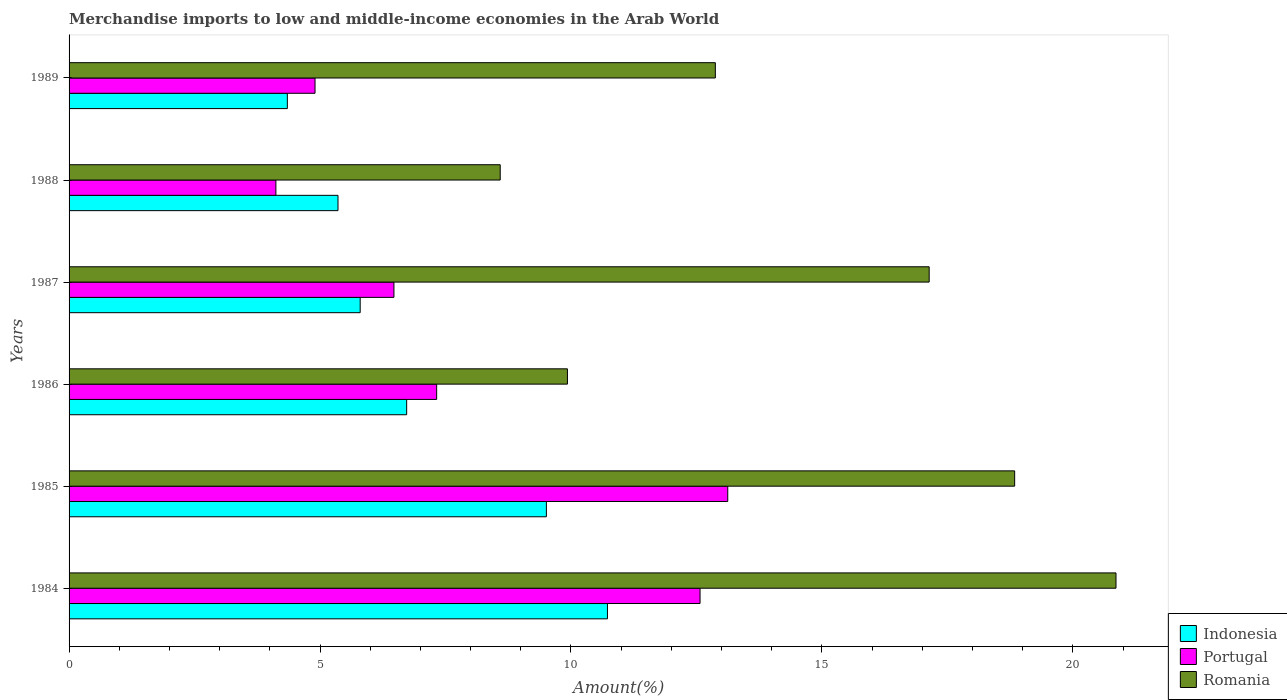How many different coloured bars are there?
Provide a succinct answer. 3. How many groups of bars are there?
Ensure brevity in your answer.  6. Are the number of bars per tick equal to the number of legend labels?
Your response must be concise. Yes. How many bars are there on the 5th tick from the top?
Your answer should be compact. 3. What is the label of the 1st group of bars from the top?
Provide a short and direct response. 1989. What is the percentage of amount earned from merchandise imports in Romania in 1986?
Give a very brief answer. 9.93. Across all years, what is the maximum percentage of amount earned from merchandise imports in Romania?
Ensure brevity in your answer.  20.86. Across all years, what is the minimum percentage of amount earned from merchandise imports in Indonesia?
Provide a succinct answer. 4.35. In which year was the percentage of amount earned from merchandise imports in Portugal maximum?
Offer a terse response. 1985. In which year was the percentage of amount earned from merchandise imports in Romania minimum?
Provide a short and direct response. 1988. What is the total percentage of amount earned from merchandise imports in Romania in the graph?
Make the answer very short. 88.24. What is the difference between the percentage of amount earned from merchandise imports in Portugal in 1985 and that in 1988?
Your response must be concise. 9. What is the difference between the percentage of amount earned from merchandise imports in Romania in 1987 and the percentage of amount earned from merchandise imports in Portugal in 1984?
Make the answer very short. 4.57. What is the average percentage of amount earned from merchandise imports in Indonesia per year?
Your answer should be very brief. 7.08. In the year 1988, what is the difference between the percentage of amount earned from merchandise imports in Romania and percentage of amount earned from merchandise imports in Indonesia?
Your response must be concise. 3.23. In how many years, is the percentage of amount earned from merchandise imports in Indonesia greater than 5 %?
Give a very brief answer. 5. What is the ratio of the percentage of amount earned from merchandise imports in Portugal in 1987 to that in 1989?
Your answer should be very brief. 1.32. Is the percentage of amount earned from merchandise imports in Indonesia in 1986 less than that in 1987?
Offer a very short reply. No. What is the difference between the highest and the second highest percentage of amount earned from merchandise imports in Indonesia?
Keep it short and to the point. 1.22. What is the difference between the highest and the lowest percentage of amount earned from merchandise imports in Romania?
Keep it short and to the point. 12.27. Is the sum of the percentage of amount earned from merchandise imports in Indonesia in 1984 and 1988 greater than the maximum percentage of amount earned from merchandise imports in Romania across all years?
Your answer should be very brief. No. What does the 1st bar from the top in 1988 represents?
Offer a very short reply. Romania. What does the 3rd bar from the bottom in 1986 represents?
Your response must be concise. Romania. How many years are there in the graph?
Make the answer very short. 6. What is the difference between two consecutive major ticks on the X-axis?
Ensure brevity in your answer.  5. Are the values on the major ticks of X-axis written in scientific E-notation?
Your answer should be very brief. No. How are the legend labels stacked?
Provide a succinct answer. Vertical. What is the title of the graph?
Keep it short and to the point. Merchandise imports to low and middle-income economies in the Arab World. What is the label or title of the X-axis?
Your answer should be compact. Amount(%). What is the Amount(%) of Indonesia in 1984?
Offer a very short reply. 10.73. What is the Amount(%) of Portugal in 1984?
Keep it short and to the point. 12.57. What is the Amount(%) of Romania in 1984?
Make the answer very short. 20.86. What is the Amount(%) of Indonesia in 1985?
Your answer should be compact. 9.51. What is the Amount(%) of Portugal in 1985?
Offer a very short reply. 13.12. What is the Amount(%) of Romania in 1985?
Your answer should be very brief. 18.84. What is the Amount(%) of Indonesia in 1986?
Give a very brief answer. 6.73. What is the Amount(%) in Portugal in 1986?
Keep it short and to the point. 7.32. What is the Amount(%) of Romania in 1986?
Offer a terse response. 9.93. What is the Amount(%) in Indonesia in 1987?
Offer a terse response. 5.8. What is the Amount(%) of Portugal in 1987?
Provide a short and direct response. 6.47. What is the Amount(%) of Romania in 1987?
Your response must be concise. 17.14. What is the Amount(%) in Indonesia in 1988?
Provide a short and direct response. 5.36. What is the Amount(%) in Portugal in 1988?
Your answer should be compact. 4.12. What is the Amount(%) of Romania in 1988?
Your response must be concise. 8.59. What is the Amount(%) of Indonesia in 1989?
Make the answer very short. 4.35. What is the Amount(%) in Portugal in 1989?
Make the answer very short. 4.9. What is the Amount(%) of Romania in 1989?
Give a very brief answer. 12.88. Across all years, what is the maximum Amount(%) of Indonesia?
Offer a terse response. 10.73. Across all years, what is the maximum Amount(%) of Portugal?
Provide a short and direct response. 13.12. Across all years, what is the maximum Amount(%) in Romania?
Offer a very short reply. 20.86. Across all years, what is the minimum Amount(%) of Indonesia?
Your answer should be very brief. 4.35. Across all years, what is the minimum Amount(%) in Portugal?
Offer a very short reply. 4.12. Across all years, what is the minimum Amount(%) in Romania?
Keep it short and to the point. 8.59. What is the total Amount(%) of Indonesia in the graph?
Offer a terse response. 42.47. What is the total Amount(%) of Portugal in the graph?
Your answer should be very brief. 48.52. What is the total Amount(%) in Romania in the graph?
Make the answer very short. 88.24. What is the difference between the Amount(%) of Indonesia in 1984 and that in 1985?
Ensure brevity in your answer.  1.22. What is the difference between the Amount(%) of Portugal in 1984 and that in 1985?
Keep it short and to the point. -0.55. What is the difference between the Amount(%) of Romania in 1984 and that in 1985?
Give a very brief answer. 2.02. What is the difference between the Amount(%) in Indonesia in 1984 and that in 1986?
Make the answer very short. 4. What is the difference between the Amount(%) in Portugal in 1984 and that in 1986?
Give a very brief answer. 5.25. What is the difference between the Amount(%) of Romania in 1984 and that in 1986?
Your answer should be very brief. 10.93. What is the difference between the Amount(%) of Indonesia in 1984 and that in 1987?
Make the answer very short. 4.93. What is the difference between the Amount(%) of Portugal in 1984 and that in 1987?
Provide a short and direct response. 6.1. What is the difference between the Amount(%) of Romania in 1984 and that in 1987?
Give a very brief answer. 3.72. What is the difference between the Amount(%) in Indonesia in 1984 and that in 1988?
Offer a very short reply. 5.37. What is the difference between the Amount(%) of Portugal in 1984 and that in 1988?
Offer a terse response. 8.45. What is the difference between the Amount(%) of Romania in 1984 and that in 1988?
Ensure brevity in your answer.  12.27. What is the difference between the Amount(%) of Indonesia in 1984 and that in 1989?
Give a very brief answer. 6.38. What is the difference between the Amount(%) of Portugal in 1984 and that in 1989?
Ensure brevity in your answer.  7.67. What is the difference between the Amount(%) in Romania in 1984 and that in 1989?
Make the answer very short. 7.98. What is the difference between the Amount(%) in Indonesia in 1985 and that in 1986?
Keep it short and to the point. 2.78. What is the difference between the Amount(%) in Portugal in 1985 and that in 1986?
Offer a terse response. 5.8. What is the difference between the Amount(%) in Romania in 1985 and that in 1986?
Give a very brief answer. 8.91. What is the difference between the Amount(%) in Indonesia in 1985 and that in 1987?
Make the answer very short. 3.71. What is the difference between the Amount(%) of Portugal in 1985 and that in 1987?
Offer a very short reply. 6.65. What is the difference between the Amount(%) of Romania in 1985 and that in 1987?
Your response must be concise. 1.7. What is the difference between the Amount(%) in Indonesia in 1985 and that in 1988?
Make the answer very short. 4.15. What is the difference between the Amount(%) in Portugal in 1985 and that in 1988?
Provide a short and direct response. 9. What is the difference between the Amount(%) of Romania in 1985 and that in 1988?
Provide a short and direct response. 10.25. What is the difference between the Amount(%) of Indonesia in 1985 and that in 1989?
Your response must be concise. 5.16. What is the difference between the Amount(%) of Portugal in 1985 and that in 1989?
Offer a very short reply. 8.22. What is the difference between the Amount(%) of Romania in 1985 and that in 1989?
Ensure brevity in your answer.  5.96. What is the difference between the Amount(%) in Indonesia in 1986 and that in 1987?
Ensure brevity in your answer.  0.93. What is the difference between the Amount(%) of Portugal in 1986 and that in 1987?
Your answer should be compact. 0.85. What is the difference between the Amount(%) of Romania in 1986 and that in 1987?
Ensure brevity in your answer.  -7.21. What is the difference between the Amount(%) of Indonesia in 1986 and that in 1988?
Give a very brief answer. 1.37. What is the difference between the Amount(%) of Portugal in 1986 and that in 1988?
Offer a terse response. 3.2. What is the difference between the Amount(%) in Romania in 1986 and that in 1988?
Make the answer very short. 1.34. What is the difference between the Amount(%) in Indonesia in 1986 and that in 1989?
Provide a succinct answer. 2.38. What is the difference between the Amount(%) of Portugal in 1986 and that in 1989?
Your answer should be compact. 2.42. What is the difference between the Amount(%) in Romania in 1986 and that in 1989?
Make the answer very short. -2.95. What is the difference between the Amount(%) of Indonesia in 1987 and that in 1988?
Your answer should be very brief. 0.44. What is the difference between the Amount(%) in Portugal in 1987 and that in 1988?
Offer a very short reply. 2.35. What is the difference between the Amount(%) of Romania in 1987 and that in 1988?
Ensure brevity in your answer.  8.55. What is the difference between the Amount(%) in Indonesia in 1987 and that in 1989?
Offer a very short reply. 1.45. What is the difference between the Amount(%) of Portugal in 1987 and that in 1989?
Provide a succinct answer. 1.57. What is the difference between the Amount(%) of Romania in 1987 and that in 1989?
Provide a short and direct response. 4.26. What is the difference between the Amount(%) in Indonesia in 1988 and that in 1989?
Your answer should be compact. 1.01. What is the difference between the Amount(%) of Portugal in 1988 and that in 1989?
Make the answer very short. -0.78. What is the difference between the Amount(%) in Romania in 1988 and that in 1989?
Give a very brief answer. -4.29. What is the difference between the Amount(%) of Indonesia in 1984 and the Amount(%) of Portugal in 1985?
Ensure brevity in your answer.  -2.4. What is the difference between the Amount(%) of Indonesia in 1984 and the Amount(%) of Romania in 1985?
Keep it short and to the point. -8.11. What is the difference between the Amount(%) of Portugal in 1984 and the Amount(%) of Romania in 1985?
Give a very brief answer. -6.27. What is the difference between the Amount(%) of Indonesia in 1984 and the Amount(%) of Portugal in 1986?
Your answer should be compact. 3.4. What is the difference between the Amount(%) of Indonesia in 1984 and the Amount(%) of Romania in 1986?
Keep it short and to the point. 0.8. What is the difference between the Amount(%) in Portugal in 1984 and the Amount(%) in Romania in 1986?
Keep it short and to the point. 2.64. What is the difference between the Amount(%) of Indonesia in 1984 and the Amount(%) of Portugal in 1987?
Make the answer very short. 4.25. What is the difference between the Amount(%) of Indonesia in 1984 and the Amount(%) of Romania in 1987?
Give a very brief answer. -6.41. What is the difference between the Amount(%) in Portugal in 1984 and the Amount(%) in Romania in 1987?
Your answer should be very brief. -4.57. What is the difference between the Amount(%) of Indonesia in 1984 and the Amount(%) of Portugal in 1988?
Provide a short and direct response. 6.61. What is the difference between the Amount(%) in Indonesia in 1984 and the Amount(%) in Romania in 1988?
Provide a short and direct response. 2.14. What is the difference between the Amount(%) of Portugal in 1984 and the Amount(%) of Romania in 1988?
Provide a succinct answer. 3.98. What is the difference between the Amount(%) of Indonesia in 1984 and the Amount(%) of Portugal in 1989?
Your response must be concise. 5.83. What is the difference between the Amount(%) in Indonesia in 1984 and the Amount(%) in Romania in 1989?
Provide a short and direct response. -2.15. What is the difference between the Amount(%) in Portugal in 1984 and the Amount(%) in Romania in 1989?
Your answer should be compact. -0.3. What is the difference between the Amount(%) in Indonesia in 1985 and the Amount(%) in Portugal in 1986?
Your response must be concise. 2.19. What is the difference between the Amount(%) of Indonesia in 1985 and the Amount(%) of Romania in 1986?
Offer a terse response. -0.42. What is the difference between the Amount(%) in Portugal in 1985 and the Amount(%) in Romania in 1986?
Your response must be concise. 3.19. What is the difference between the Amount(%) in Indonesia in 1985 and the Amount(%) in Portugal in 1987?
Provide a short and direct response. 3.04. What is the difference between the Amount(%) in Indonesia in 1985 and the Amount(%) in Romania in 1987?
Make the answer very short. -7.63. What is the difference between the Amount(%) in Portugal in 1985 and the Amount(%) in Romania in 1987?
Your answer should be compact. -4.01. What is the difference between the Amount(%) in Indonesia in 1985 and the Amount(%) in Portugal in 1988?
Provide a short and direct response. 5.39. What is the difference between the Amount(%) of Indonesia in 1985 and the Amount(%) of Romania in 1988?
Provide a short and direct response. 0.92. What is the difference between the Amount(%) in Portugal in 1985 and the Amount(%) in Romania in 1988?
Give a very brief answer. 4.53. What is the difference between the Amount(%) of Indonesia in 1985 and the Amount(%) of Portugal in 1989?
Your answer should be very brief. 4.61. What is the difference between the Amount(%) in Indonesia in 1985 and the Amount(%) in Romania in 1989?
Your answer should be very brief. -3.37. What is the difference between the Amount(%) of Portugal in 1985 and the Amount(%) of Romania in 1989?
Provide a short and direct response. 0.25. What is the difference between the Amount(%) in Indonesia in 1986 and the Amount(%) in Portugal in 1987?
Offer a terse response. 0.25. What is the difference between the Amount(%) of Indonesia in 1986 and the Amount(%) of Romania in 1987?
Provide a short and direct response. -10.41. What is the difference between the Amount(%) in Portugal in 1986 and the Amount(%) in Romania in 1987?
Give a very brief answer. -9.81. What is the difference between the Amount(%) of Indonesia in 1986 and the Amount(%) of Portugal in 1988?
Ensure brevity in your answer.  2.61. What is the difference between the Amount(%) in Indonesia in 1986 and the Amount(%) in Romania in 1988?
Offer a terse response. -1.86. What is the difference between the Amount(%) in Portugal in 1986 and the Amount(%) in Romania in 1988?
Provide a succinct answer. -1.27. What is the difference between the Amount(%) of Indonesia in 1986 and the Amount(%) of Portugal in 1989?
Keep it short and to the point. 1.83. What is the difference between the Amount(%) in Indonesia in 1986 and the Amount(%) in Romania in 1989?
Offer a terse response. -6.15. What is the difference between the Amount(%) in Portugal in 1986 and the Amount(%) in Romania in 1989?
Offer a terse response. -5.55. What is the difference between the Amount(%) in Indonesia in 1987 and the Amount(%) in Portugal in 1988?
Offer a very short reply. 1.68. What is the difference between the Amount(%) in Indonesia in 1987 and the Amount(%) in Romania in 1988?
Give a very brief answer. -2.79. What is the difference between the Amount(%) of Portugal in 1987 and the Amount(%) of Romania in 1988?
Keep it short and to the point. -2.12. What is the difference between the Amount(%) in Indonesia in 1987 and the Amount(%) in Romania in 1989?
Provide a short and direct response. -7.08. What is the difference between the Amount(%) of Portugal in 1987 and the Amount(%) of Romania in 1989?
Provide a succinct answer. -6.4. What is the difference between the Amount(%) of Indonesia in 1988 and the Amount(%) of Portugal in 1989?
Provide a succinct answer. 0.46. What is the difference between the Amount(%) in Indonesia in 1988 and the Amount(%) in Romania in 1989?
Your response must be concise. -7.52. What is the difference between the Amount(%) of Portugal in 1988 and the Amount(%) of Romania in 1989?
Your answer should be very brief. -8.76. What is the average Amount(%) of Indonesia per year?
Ensure brevity in your answer.  7.08. What is the average Amount(%) in Portugal per year?
Ensure brevity in your answer.  8.09. What is the average Amount(%) in Romania per year?
Ensure brevity in your answer.  14.71. In the year 1984, what is the difference between the Amount(%) of Indonesia and Amount(%) of Portugal?
Your answer should be very brief. -1.84. In the year 1984, what is the difference between the Amount(%) in Indonesia and Amount(%) in Romania?
Keep it short and to the point. -10.13. In the year 1984, what is the difference between the Amount(%) in Portugal and Amount(%) in Romania?
Your answer should be compact. -8.29. In the year 1985, what is the difference between the Amount(%) in Indonesia and Amount(%) in Portugal?
Provide a succinct answer. -3.61. In the year 1985, what is the difference between the Amount(%) in Indonesia and Amount(%) in Romania?
Give a very brief answer. -9.33. In the year 1985, what is the difference between the Amount(%) in Portugal and Amount(%) in Romania?
Offer a very short reply. -5.72. In the year 1986, what is the difference between the Amount(%) of Indonesia and Amount(%) of Portugal?
Ensure brevity in your answer.  -0.6. In the year 1986, what is the difference between the Amount(%) in Indonesia and Amount(%) in Romania?
Offer a terse response. -3.2. In the year 1986, what is the difference between the Amount(%) of Portugal and Amount(%) of Romania?
Give a very brief answer. -2.61. In the year 1987, what is the difference between the Amount(%) of Indonesia and Amount(%) of Portugal?
Offer a very short reply. -0.67. In the year 1987, what is the difference between the Amount(%) of Indonesia and Amount(%) of Romania?
Make the answer very short. -11.34. In the year 1987, what is the difference between the Amount(%) in Portugal and Amount(%) in Romania?
Ensure brevity in your answer.  -10.66. In the year 1988, what is the difference between the Amount(%) in Indonesia and Amount(%) in Portugal?
Provide a succinct answer. 1.24. In the year 1988, what is the difference between the Amount(%) in Indonesia and Amount(%) in Romania?
Keep it short and to the point. -3.23. In the year 1988, what is the difference between the Amount(%) of Portugal and Amount(%) of Romania?
Your answer should be compact. -4.47. In the year 1989, what is the difference between the Amount(%) in Indonesia and Amount(%) in Portugal?
Offer a terse response. -0.55. In the year 1989, what is the difference between the Amount(%) of Indonesia and Amount(%) of Romania?
Make the answer very short. -8.53. In the year 1989, what is the difference between the Amount(%) in Portugal and Amount(%) in Romania?
Make the answer very short. -7.98. What is the ratio of the Amount(%) in Indonesia in 1984 to that in 1985?
Give a very brief answer. 1.13. What is the ratio of the Amount(%) of Portugal in 1984 to that in 1985?
Your answer should be very brief. 0.96. What is the ratio of the Amount(%) in Romania in 1984 to that in 1985?
Offer a terse response. 1.11. What is the ratio of the Amount(%) in Indonesia in 1984 to that in 1986?
Your answer should be very brief. 1.59. What is the ratio of the Amount(%) in Portugal in 1984 to that in 1986?
Make the answer very short. 1.72. What is the ratio of the Amount(%) in Romania in 1984 to that in 1986?
Provide a succinct answer. 2.1. What is the ratio of the Amount(%) of Indonesia in 1984 to that in 1987?
Provide a succinct answer. 1.85. What is the ratio of the Amount(%) of Portugal in 1984 to that in 1987?
Your response must be concise. 1.94. What is the ratio of the Amount(%) of Romania in 1984 to that in 1987?
Offer a very short reply. 1.22. What is the ratio of the Amount(%) in Indonesia in 1984 to that in 1988?
Keep it short and to the point. 2. What is the ratio of the Amount(%) in Portugal in 1984 to that in 1988?
Ensure brevity in your answer.  3.05. What is the ratio of the Amount(%) in Romania in 1984 to that in 1988?
Make the answer very short. 2.43. What is the ratio of the Amount(%) of Indonesia in 1984 to that in 1989?
Provide a succinct answer. 2.47. What is the ratio of the Amount(%) of Portugal in 1984 to that in 1989?
Ensure brevity in your answer.  2.57. What is the ratio of the Amount(%) of Romania in 1984 to that in 1989?
Ensure brevity in your answer.  1.62. What is the ratio of the Amount(%) in Indonesia in 1985 to that in 1986?
Your answer should be compact. 1.41. What is the ratio of the Amount(%) in Portugal in 1985 to that in 1986?
Provide a short and direct response. 1.79. What is the ratio of the Amount(%) of Romania in 1985 to that in 1986?
Give a very brief answer. 1.9. What is the ratio of the Amount(%) of Indonesia in 1985 to that in 1987?
Offer a very short reply. 1.64. What is the ratio of the Amount(%) of Portugal in 1985 to that in 1987?
Offer a very short reply. 2.03. What is the ratio of the Amount(%) in Romania in 1985 to that in 1987?
Make the answer very short. 1.1. What is the ratio of the Amount(%) of Indonesia in 1985 to that in 1988?
Your response must be concise. 1.77. What is the ratio of the Amount(%) of Portugal in 1985 to that in 1988?
Offer a terse response. 3.18. What is the ratio of the Amount(%) in Romania in 1985 to that in 1988?
Give a very brief answer. 2.19. What is the ratio of the Amount(%) in Indonesia in 1985 to that in 1989?
Offer a very short reply. 2.19. What is the ratio of the Amount(%) of Portugal in 1985 to that in 1989?
Your response must be concise. 2.68. What is the ratio of the Amount(%) in Romania in 1985 to that in 1989?
Make the answer very short. 1.46. What is the ratio of the Amount(%) of Indonesia in 1986 to that in 1987?
Keep it short and to the point. 1.16. What is the ratio of the Amount(%) in Portugal in 1986 to that in 1987?
Provide a short and direct response. 1.13. What is the ratio of the Amount(%) of Romania in 1986 to that in 1987?
Your response must be concise. 0.58. What is the ratio of the Amount(%) in Indonesia in 1986 to that in 1988?
Offer a terse response. 1.26. What is the ratio of the Amount(%) of Portugal in 1986 to that in 1988?
Your answer should be compact. 1.78. What is the ratio of the Amount(%) of Romania in 1986 to that in 1988?
Provide a succinct answer. 1.16. What is the ratio of the Amount(%) of Indonesia in 1986 to that in 1989?
Ensure brevity in your answer.  1.55. What is the ratio of the Amount(%) in Portugal in 1986 to that in 1989?
Provide a short and direct response. 1.49. What is the ratio of the Amount(%) of Romania in 1986 to that in 1989?
Make the answer very short. 0.77. What is the ratio of the Amount(%) in Indonesia in 1987 to that in 1988?
Offer a very short reply. 1.08. What is the ratio of the Amount(%) of Portugal in 1987 to that in 1988?
Offer a very short reply. 1.57. What is the ratio of the Amount(%) in Romania in 1987 to that in 1988?
Offer a very short reply. 1.99. What is the ratio of the Amount(%) of Indonesia in 1987 to that in 1989?
Give a very brief answer. 1.33. What is the ratio of the Amount(%) of Portugal in 1987 to that in 1989?
Ensure brevity in your answer.  1.32. What is the ratio of the Amount(%) of Romania in 1987 to that in 1989?
Keep it short and to the point. 1.33. What is the ratio of the Amount(%) in Indonesia in 1988 to that in 1989?
Your answer should be compact. 1.23. What is the ratio of the Amount(%) of Portugal in 1988 to that in 1989?
Give a very brief answer. 0.84. What is the ratio of the Amount(%) of Romania in 1988 to that in 1989?
Offer a terse response. 0.67. What is the difference between the highest and the second highest Amount(%) of Indonesia?
Give a very brief answer. 1.22. What is the difference between the highest and the second highest Amount(%) in Portugal?
Provide a succinct answer. 0.55. What is the difference between the highest and the second highest Amount(%) of Romania?
Provide a succinct answer. 2.02. What is the difference between the highest and the lowest Amount(%) in Indonesia?
Give a very brief answer. 6.38. What is the difference between the highest and the lowest Amount(%) in Portugal?
Your response must be concise. 9. What is the difference between the highest and the lowest Amount(%) of Romania?
Offer a terse response. 12.27. 